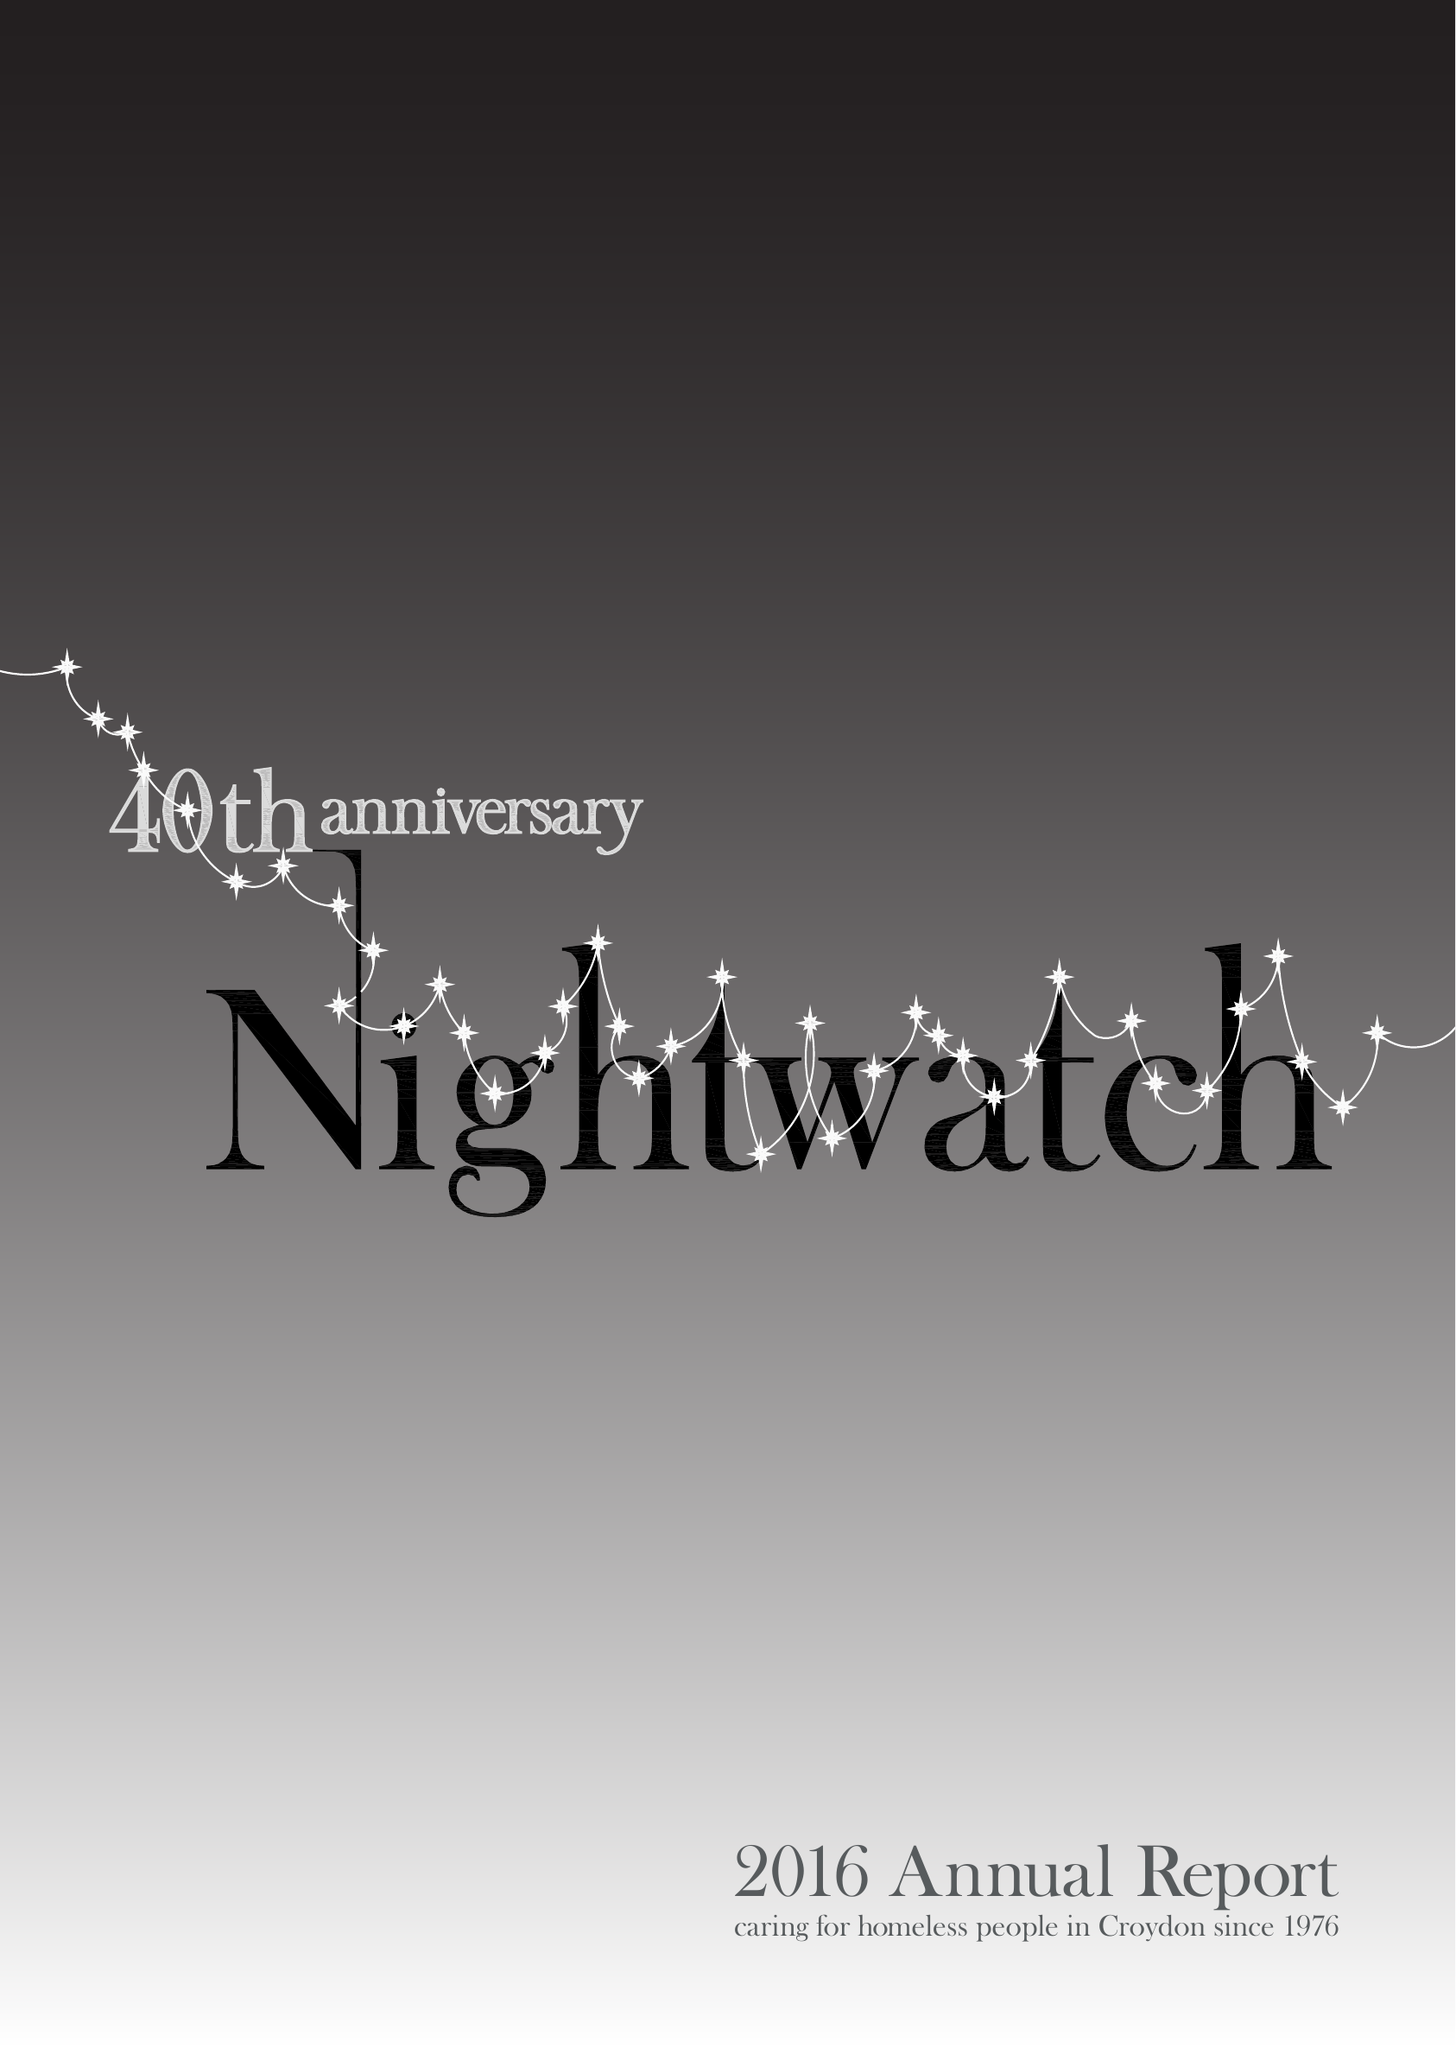What is the value for the income_annually_in_british_pounds?
Answer the question using a single word or phrase. 48422.00 